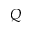Convert formula to latex. <formula><loc_0><loc_0><loc_500><loc_500>Q</formula> 